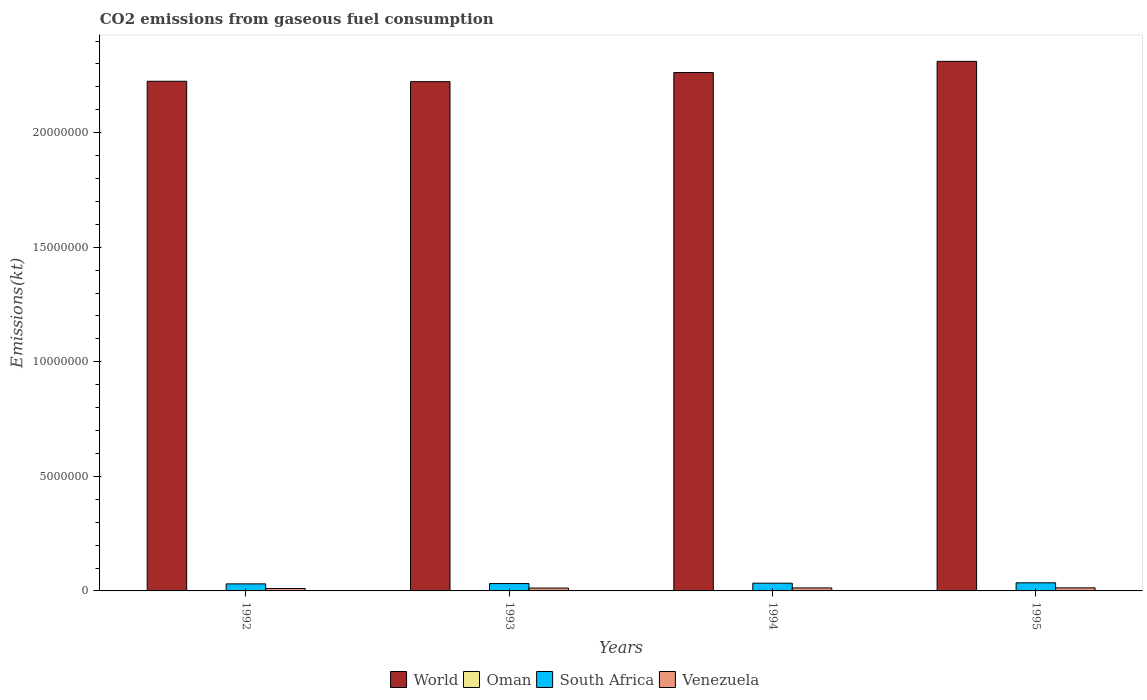How many different coloured bars are there?
Provide a short and direct response. 4. How many groups of bars are there?
Keep it short and to the point. 4. Are the number of bars on each tick of the X-axis equal?
Your answer should be very brief. Yes. How many bars are there on the 4th tick from the right?
Offer a terse response. 4. What is the label of the 2nd group of bars from the left?
Provide a succinct answer. 1993. What is the amount of CO2 emitted in South Africa in 1993?
Offer a terse response. 3.21e+05. Across all years, what is the maximum amount of CO2 emitted in World?
Provide a short and direct response. 2.31e+07. Across all years, what is the minimum amount of CO2 emitted in Venezuela?
Provide a succinct answer. 1.06e+05. In which year was the amount of CO2 emitted in Venezuela minimum?
Your answer should be compact. 1992. What is the total amount of CO2 emitted in World in the graph?
Your response must be concise. 9.02e+07. What is the difference between the amount of CO2 emitted in South Africa in 1994 and that in 1995?
Ensure brevity in your answer.  -1.59e+04. What is the difference between the amount of CO2 emitted in Venezuela in 1992 and the amount of CO2 emitted in World in 1994?
Ensure brevity in your answer.  -2.25e+07. What is the average amount of CO2 emitted in World per year?
Offer a terse response. 2.26e+07. In the year 1995, what is the difference between the amount of CO2 emitted in Oman and amount of CO2 emitted in South Africa?
Ensure brevity in your answer.  -3.38e+05. In how many years, is the amount of CO2 emitted in World greater than 21000000 kt?
Your answer should be very brief. 4. What is the ratio of the amount of CO2 emitted in World in 1992 to that in 1993?
Keep it short and to the point. 1. Is the amount of CO2 emitted in Venezuela in 1993 less than that in 1994?
Provide a succinct answer. Yes. Is the difference between the amount of CO2 emitted in Oman in 1993 and 1994 greater than the difference between the amount of CO2 emitted in South Africa in 1993 and 1994?
Give a very brief answer. Yes. What is the difference between the highest and the second highest amount of CO2 emitted in South Africa?
Offer a terse response. 1.59e+04. What is the difference between the highest and the lowest amount of CO2 emitted in Oman?
Provide a short and direct response. 3817.35. In how many years, is the amount of CO2 emitted in Venezuela greater than the average amount of CO2 emitted in Venezuela taken over all years?
Offer a terse response. 3. What does the 2nd bar from the left in 1993 represents?
Your response must be concise. Oman. What does the 1st bar from the right in 1994 represents?
Your answer should be compact. Venezuela. How many bars are there?
Offer a very short reply. 16. Are all the bars in the graph horizontal?
Offer a very short reply. No. What is the title of the graph?
Your answer should be compact. CO2 emissions from gaseous fuel consumption. Does "Philippines" appear as one of the legend labels in the graph?
Offer a terse response. No. What is the label or title of the Y-axis?
Ensure brevity in your answer.  Emissions(kt). What is the Emissions(kt) in World in 1992?
Provide a short and direct response. 2.22e+07. What is the Emissions(kt) in Oman in 1992?
Offer a very short reply. 1.21e+04. What is the Emissions(kt) in South Africa in 1992?
Your answer should be compact. 3.08e+05. What is the Emissions(kt) of Venezuela in 1992?
Offer a very short reply. 1.06e+05. What is the Emissions(kt) of World in 1993?
Provide a succinct answer. 2.22e+07. What is the Emissions(kt) of Oman in 1993?
Keep it short and to the point. 1.35e+04. What is the Emissions(kt) of South Africa in 1993?
Provide a short and direct response. 3.21e+05. What is the Emissions(kt) in Venezuela in 1993?
Provide a short and direct response. 1.24e+05. What is the Emissions(kt) of World in 1994?
Provide a succinct answer. 2.26e+07. What is the Emissions(kt) in Oman in 1994?
Offer a very short reply. 1.53e+04. What is the Emissions(kt) of South Africa in 1994?
Keep it short and to the point. 3.38e+05. What is the Emissions(kt) in Venezuela in 1994?
Ensure brevity in your answer.  1.30e+05. What is the Emissions(kt) in World in 1995?
Provide a succinct answer. 2.31e+07. What is the Emissions(kt) of Oman in 1995?
Keep it short and to the point. 1.59e+04. What is the Emissions(kt) in South Africa in 1995?
Offer a terse response. 3.53e+05. What is the Emissions(kt) in Venezuela in 1995?
Ensure brevity in your answer.  1.33e+05. Across all years, what is the maximum Emissions(kt) of World?
Ensure brevity in your answer.  2.31e+07. Across all years, what is the maximum Emissions(kt) of Oman?
Offer a very short reply. 1.59e+04. Across all years, what is the maximum Emissions(kt) in South Africa?
Offer a terse response. 3.53e+05. Across all years, what is the maximum Emissions(kt) of Venezuela?
Your answer should be very brief. 1.33e+05. Across all years, what is the minimum Emissions(kt) of World?
Keep it short and to the point. 2.22e+07. Across all years, what is the minimum Emissions(kt) in Oman?
Offer a very short reply. 1.21e+04. Across all years, what is the minimum Emissions(kt) of South Africa?
Your answer should be very brief. 3.08e+05. Across all years, what is the minimum Emissions(kt) in Venezuela?
Offer a very short reply. 1.06e+05. What is the total Emissions(kt) in World in the graph?
Keep it short and to the point. 9.02e+07. What is the total Emissions(kt) in Oman in the graph?
Your answer should be compact. 5.67e+04. What is the total Emissions(kt) in South Africa in the graph?
Offer a terse response. 1.32e+06. What is the total Emissions(kt) in Venezuela in the graph?
Your response must be concise. 4.94e+05. What is the difference between the Emissions(kt) of World in 1992 and that in 1993?
Your answer should be very brief. 1.77e+04. What is the difference between the Emissions(kt) in Oman in 1992 and that in 1993?
Ensure brevity in your answer.  -1378.79. What is the difference between the Emissions(kt) in South Africa in 1992 and that in 1993?
Give a very brief answer. -1.33e+04. What is the difference between the Emissions(kt) of Venezuela in 1992 and that in 1993?
Give a very brief answer. -1.84e+04. What is the difference between the Emissions(kt) in World in 1992 and that in 1994?
Provide a succinct answer. -3.81e+05. What is the difference between the Emissions(kt) of Oman in 1992 and that in 1994?
Give a very brief answer. -3226.96. What is the difference between the Emissions(kt) of South Africa in 1992 and that in 1994?
Keep it short and to the point. -2.98e+04. What is the difference between the Emissions(kt) of Venezuela in 1992 and that in 1994?
Provide a short and direct response. -2.40e+04. What is the difference between the Emissions(kt) of World in 1992 and that in 1995?
Make the answer very short. -8.69e+05. What is the difference between the Emissions(kt) in Oman in 1992 and that in 1995?
Ensure brevity in your answer.  -3817.35. What is the difference between the Emissions(kt) in South Africa in 1992 and that in 1995?
Provide a short and direct response. -4.56e+04. What is the difference between the Emissions(kt) in Venezuela in 1992 and that in 1995?
Give a very brief answer. -2.74e+04. What is the difference between the Emissions(kt) of World in 1993 and that in 1994?
Offer a very short reply. -3.99e+05. What is the difference between the Emissions(kt) of Oman in 1993 and that in 1994?
Offer a terse response. -1848.17. What is the difference between the Emissions(kt) in South Africa in 1993 and that in 1994?
Ensure brevity in your answer.  -1.65e+04. What is the difference between the Emissions(kt) in Venezuela in 1993 and that in 1994?
Provide a short and direct response. -5573.84. What is the difference between the Emissions(kt) in World in 1993 and that in 1995?
Your answer should be very brief. -8.87e+05. What is the difference between the Emissions(kt) in Oman in 1993 and that in 1995?
Provide a succinct answer. -2438.55. What is the difference between the Emissions(kt) in South Africa in 1993 and that in 1995?
Provide a short and direct response. -3.24e+04. What is the difference between the Emissions(kt) of Venezuela in 1993 and that in 1995?
Your response must be concise. -8958.48. What is the difference between the Emissions(kt) in World in 1994 and that in 1995?
Your answer should be compact. -4.88e+05. What is the difference between the Emissions(kt) in Oman in 1994 and that in 1995?
Provide a succinct answer. -590.39. What is the difference between the Emissions(kt) of South Africa in 1994 and that in 1995?
Your answer should be compact. -1.59e+04. What is the difference between the Emissions(kt) in Venezuela in 1994 and that in 1995?
Provide a succinct answer. -3384.64. What is the difference between the Emissions(kt) of World in 1992 and the Emissions(kt) of Oman in 1993?
Your answer should be compact. 2.22e+07. What is the difference between the Emissions(kt) in World in 1992 and the Emissions(kt) in South Africa in 1993?
Make the answer very short. 2.19e+07. What is the difference between the Emissions(kt) of World in 1992 and the Emissions(kt) of Venezuela in 1993?
Keep it short and to the point. 2.21e+07. What is the difference between the Emissions(kt) in Oman in 1992 and the Emissions(kt) in South Africa in 1993?
Offer a very short reply. -3.09e+05. What is the difference between the Emissions(kt) of Oman in 1992 and the Emissions(kt) of Venezuela in 1993?
Ensure brevity in your answer.  -1.12e+05. What is the difference between the Emissions(kt) in South Africa in 1992 and the Emissions(kt) in Venezuela in 1993?
Offer a terse response. 1.83e+05. What is the difference between the Emissions(kt) in World in 1992 and the Emissions(kt) in Oman in 1994?
Ensure brevity in your answer.  2.22e+07. What is the difference between the Emissions(kt) of World in 1992 and the Emissions(kt) of South Africa in 1994?
Your answer should be compact. 2.19e+07. What is the difference between the Emissions(kt) in World in 1992 and the Emissions(kt) in Venezuela in 1994?
Your answer should be compact. 2.21e+07. What is the difference between the Emissions(kt) in Oman in 1992 and the Emissions(kt) in South Africa in 1994?
Provide a short and direct response. -3.25e+05. What is the difference between the Emissions(kt) in Oman in 1992 and the Emissions(kt) in Venezuela in 1994?
Offer a very short reply. -1.18e+05. What is the difference between the Emissions(kt) of South Africa in 1992 and the Emissions(kt) of Venezuela in 1994?
Make the answer very short. 1.78e+05. What is the difference between the Emissions(kt) of World in 1992 and the Emissions(kt) of Oman in 1995?
Offer a terse response. 2.22e+07. What is the difference between the Emissions(kt) of World in 1992 and the Emissions(kt) of South Africa in 1995?
Provide a short and direct response. 2.19e+07. What is the difference between the Emissions(kt) of World in 1992 and the Emissions(kt) of Venezuela in 1995?
Your response must be concise. 2.21e+07. What is the difference between the Emissions(kt) in Oman in 1992 and the Emissions(kt) in South Africa in 1995?
Provide a succinct answer. -3.41e+05. What is the difference between the Emissions(kt) in Oman in 1992 and the Emissions(kt) in Venezuela in 1995?
Your answer should be compact. -1.21e+05. What is the difference between the Emissions(kt) in South Africa in 1992 and the Emissions(kt) in Venezuela in 1995?
Your answer should be very brief. 1.74e+05. What is the difference between the Emissions(kt) of World in 1993 and the Emissions(kt) of Oman in 1994?
Offer a terse response. 2.22e+07. What is the difference between the Emissions(kt) in World in 1993 and the Emissions(kt) in South Africa in 1994?
Make the answer very short. 2.19e+07. What is the difference between the Emissions(kt) of World in 1993 and the Emissions(kt) of Venezuela in 1994?
Provide a succinct answer. 2.21e+07. What is the difference between the Emissions(kt) of Oman in 1993 and the Emissions(kt) of South Africa in 1994?
Keep it short and to the point. -3.24e+05. What is the difference between the Emissions(kt) of Oman in 1993 and the Emissions(kt) of Venezuela in 1994?
Your response must be concise. -1.17e+05. What is the difference between the Emissions(kt) in South Africa in 1993 and the Emissions(kt) in Venezuela in 1994?
Provide a short and direct response. 1.91e+05. What is the difference between the Emissions(kt) of World in 1993 and the Emissions(kt) of Oman in 1995?
Your answer should be compact. 2.22e+07. What is the difference between the Emissions(kt) in World in 1993 and the Emissions(kt) in South Africa in 1995?
Your answer should be very brief. 2.19e+07. What is the difference between the Emissions(kt) of World in 1993 and the Emissions(kt) of Venezuela in 1995?
Your answer should be compact. 2.21e+07. What is the difference between the Emissions(kt) in Oman in 1993 and the Emissions(kt) in South Africa in 1995?
Give a very brief answer. -3.40e+05. What is the difference between the Emissions(kt) in Oman in 1993 and the Emissions(kt) in Venezuela in 1995?
Your answer should be very brief. -1.20e+05. What is the difference between the Emissions(kt) of South Africa in 1993 and the Emissions(kt) of Venezuela in 1995?
Ensure brevity in your answer.  1.88e+05. What is the difference between the Emissions(kt) in World in 1994 and the Emissions(kt) in Oman in 1995?
Your response must be concise. 2.26e+07. What is the difference between the Emissions(kt) of World in 1994 and the Emissions(kt) of South Africa in 1995?
Provide a short and direct response. 2.23e+07. What is the difference between the Emissions(kt) in World in 1994 and the Emissions(kt) in Venezuela in 1995?
Provide a succinct answer. 2.25e+07. What is the difference between the Emissions(kt) of Oman in 1994 and the Emissions(kt) of South Africa in 1995?
Your answer should be very brief. -3.38e+05. What is the difference between the Emissions(kt) in Oman in 1994 and the Emissions(kt) in Venezuela in 1995?
Offer a very short reply. -1.18e+05. What is the difference between the Emissions(kt) of South Africa in 1994 and the Emissions(kt) of Venezuela in 1995?
Your answer should be compact. 2.04e+05. What is the average Emissions(kt) of World per year?
Make the answer very short. 2.26e+07. What is the average Emissions(kt) in Oman per year?
Provide a succinct answer. 1.42e+04. What is the average Emissions(kt) in South Africa per year?
Your answer should be very brief. 3.30e+05. What is the average Emissions(kt) in Venezuela per year?
Provide a succinct answer. 1.23e+05. In the year 1992, what is the difference between the Emissions(kt) in World and Emissions(kt) in Oman?
Ensure brevity in your answer.  2.22e+07. In the year 1992, what is the difference between the Emissions(kt) of World and Emissions(kt) of South Africa?
Your answer should be very brief. 2.19e+07. In the year 1992, what is the difference between the Emissions(kt) of World and Emissions(kt) of Venezuela?
Your response must be concise. 2.21e+07. In the year 1992, what is the difference between the Emissions(kt) of Oman and Emissions(kt) of South Africa?
Your answer should be compact. -2.96e+05. In the year 1992, what is the difference between the Emissions(kt) in Oman and Emissions(kt) in Venezuela?
Keep it short and to the point. -9.39e+04. In the year 1992, what is the difference between the Emissions(kt) in South Africa and Emissions(kt) in Venezuela?
Your answer should be very brief. 2.02e+05. In the year 1993, what is the difference between the Emissions(kt) of World and Emissions(kt) of Oman?
Provide a succinct answer. 2.22e+07. In the year 1993, what is the difference between the Emissions(kt) of World and Emissions(kt) of South Africa?
Your answer should be very brief. 2.19e+07. In the year 1993, what is the difference between the Emissions(kt) of World and Emissions(kt) of Venezuela?
Offer a very short reply. 2.21e+07. In the year 1993, what is the difference between the Emissions(kt) in Oman and Emissions(kt) in South Africa?
Offer a terse response. -3.08e+05. In the year 1993, what is the difference between the Emissions(kt) of Oman and Emissions(kt) of Venezuela?
Ensure brevity in your answer.  -1.11e+05. In the year 1993, what is the difference between the Emissions(kt) of South Africa and Emissions(kt) of Venezuela?
Ensure brevity in your answer.  1.97e+05. In the year 1994, what is the difference between the Emissions(kt) of World and Emissions(kt) of Oman?
Provide a succinct answer. 2.26e+07. In the year 1994, what is the difference between the Emissions(kt) of World and Emissions(kt) of South Africa?
Provide a succinct answer. 2.23e+07. In the year 1994, what is the difference between the Emissions(kt) of World and Emissions(kt) of Venezuela?
Offer a very short reply. 2.25e+07. In the year 1994, what is the difference between the Emissions(kt) of Oman and Emissions(kt) of South Africa?
Offer a terse response. -3.22e+05. In the year 1994, what is the difference between the Emissions(kt) of Oman and Emissions(kt) of Venezuela?
Your answer should be very brief. -1.15e+05. In the year 1994, what is the difference between the Emissions(kt) of South Africa and Emissions(kt) of Venezuela?
Offer a very short reply. 2.08e+05. In the year 1995, what is the difference between the Emissions(kt) of World and Emissions(kt) of Oman?
Offer a very short reply. 2.31e+07. In the year 1995, what is the difference between the Emissions(kt) of World and Emissions(kt) of South Africa?
Keep it short and to the point. 2.28e+07. In the year 1995, what is the difference between the Emissions(kt) of World and Emissions(kt) of Venezuela?
Make the answer very short. 2.30e+07. In the year 1995, what is the difference between the Emissions(kt) of Oman and Emissions(kt) of South Africa?
Your response must be concise. -3.38e+05. In the year 1995, what is the difference between the Emissions(kt) of Oman and Emissions(kt) of Venezuela?
Your answer should be very brief. -1.17e+05. In the year 1995, what is the difference between the Emissions(kt) in South Africa and Emissions(kt) in Venezuela?
Offer a very short reply. 2.20e+05. What is the ratio of the Emissions(kt) of Oman in 1992 to that in 1993?
Provide a succinct answer. 0.9. What is the ratio of the Emissions(kt) in South Africa in 1992 to that in 1993?
Provide a short and direct response. 0.96. What is the ratio of the Emissions(kt) in Venezuela in 1992 to that in 1993?
Offer a terse response. 0.85. What is the ratio of the Emissions(kt) of World in 1992 to that in 1994?
Give a very brief answer. 0.98. What is the ratio of the Emissions(kt) in Oman in 1992 to that in 1994?
Your answer should be very brief. 0.79. What is the ratio of the Emissions(kt) in South Africa in 1992 to that in 1994?
Offer a very short reply. 0.91. What is the ratio of the Emissions(kt) in Venezuela in 1992 to that in 1994?
Your answer should be compact. 0.82. What is the ratio of the Emissions(kt) in World in 1992 to that in 1995?
Give a very brief answer. 0.96. What is the ratio of the Emissions(kt) of Oman in 1992 to that in 1995?
Provide a short and direct response. 0.76. What is the ratio of the Emissions(kt) in South Africa in 1992 to that in 1995?
Offer a terse response. 0.87. What is the ratio of the Emissions(kt) of Venezuela in 1992 to that in 1995?
Your answer should be compact. 0.79. What is the ratio of the Emissions(kt) of World in 1993 to that in 1994?
Your answer should be compact. 0.98. What is the ratio of the Emissions(kt) in Oman in 1993 to that in 1994?
Provide a succinct answer. 0.88. What is the ratio of the Emissions(kt) of South Africa in 1993 to that in 1994?
Your answer should be very brief. 0.95. What is the ratio of the Emissions(kt) of Venezuela in 1993 to that in 1994?
Keep it short and to the point. 0.96. What is the ratio of the Emissions(kt) in World in 1993 to that in 1995?
Your answer should be very brief. 0.96. What is the ratio of the Emissions(kt) in Oman in 1993 to that in 1995?
Offer a very short reply. 0.85. What is the ratio of the Emissions(kt) in South Africa in 1993 to that in 1995?
Offer a terse response. 0.91. What is the ratio of the Emissions(kt) of Venezuela in 1993 to that in 1995?
Your answer should be compact. 0.93. What is the ratio of the Emissions(kt) of World in 1994 to that in 1995?
Give a very brief answer. 0.98. What is the ratio of the Emissions(kt) in Oman in 1994 to that in 1995?
Offer a very short reply. 0.96. What is the ratio of the Emissions(kt) of South Africa in 1994 to that in 1995?
Offer a terse response. 0.96. What is the ratio of the Emissions(kt) in Venezuela in 1994 to that in 1995?
Provide a short and direct response. 0.97. What is the difference between the highest and the second highest Emissions(kt) of World?
Your response must be concise. 4.88e+05. What is the difference between the highest and the second highest Emissions(kt) of Oman?
Your response must be concise. 590.39. What is the difference between the highest and the second highest Emissions(kt) in South Africa?
Ensure brevity in your answer.  1.59e+04. What is the difference between the highest and the second highest Emissions(kt) in Venezuela?
Ensure brevity in your answer.  3384.64. What is the difference between the highest and the lowest Emissions(kt) of World?
Give a very brief answer. 8.87e+05. What is the difference between the highest and the lowest Emissions(kt) of Oman?
Give a very brief answer. 3817.35. What is the difference between the highest and the lowest Emissions(kt) in South Africa?
Offer a very short reply. 4.56e+04. What is the difference between the highest and the lowest Emissions(kt) of Venezuela?
Provide a short and direct response. 2.74e+04. 